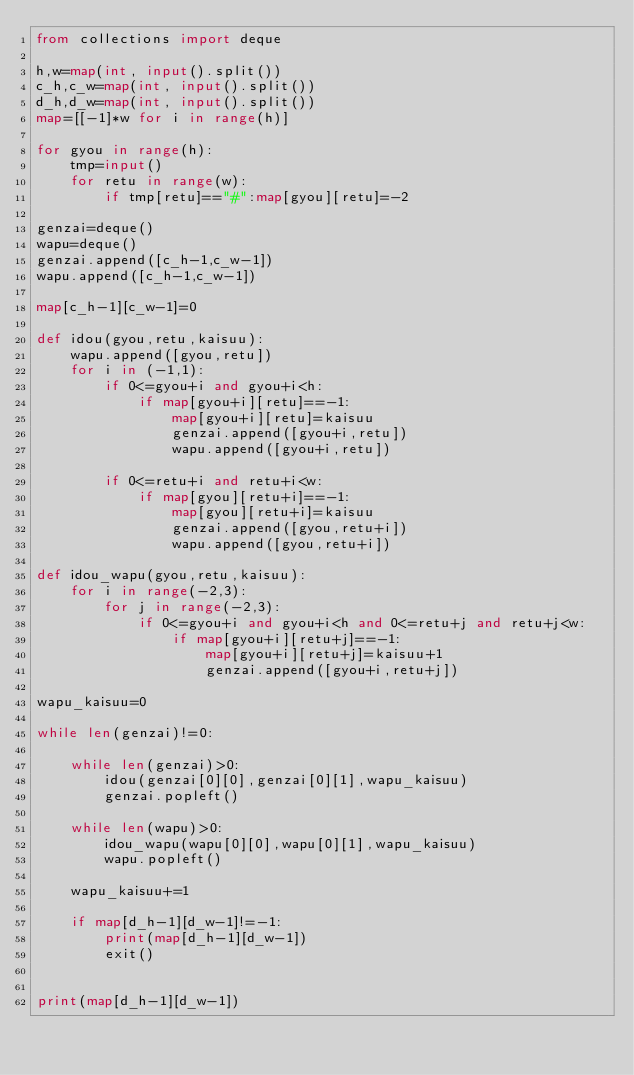<code> <loc_0><loc_0><loc_500><loc_500><_Python_>from collections import deque

h,w=map(int, input().split())
c_h,c_w=map(int, input().split())
d_h,d_w=map(int, input().split())
map=[[-1]*w for i in range(h)]
 
for gyou in range(h):
    tmp=input()
    for retu in range(w):
        if tmp[retu]=="#":map[gyou][retu]=-2
 
genzai=deque()
wapu=deque()
genzai.append([c_h-1,c_w-1])
wapu.append([c_h-1,c_w-1])
 
map[c_h-1][c_w-1]=0
 
def idou(gyou,retu,kaisuu):
    wapu.append([gyou,retu])
    for i in (-1,1):
        if 0<=gyou+i and gyou+i<h:
            if map[gyou+i][retu]==-1:
                map[gyou+i][retu]=kaisuu
                genzai.append([gyou+i,retu])
                wapu.append([gyou+i,retu])
                
        if 0<=retu+i and retu+i<w:
            if map[gyou][retu+i]==-1:
                map[gyou][retu+i]=kaisuu
                genzai.append([gyou,retu+i])
                wapu.append([gyou,retu+i])

def idou_wapu(gyou,retu,kaisuu):
    for i in range(-2,3):
        for j in range(-2,3):
            if 0<=gyou+i and gyou+i<h and 0<=retu+j and retu+j<w:
                if map[gyou+i][retu+j]==-1:
                    map[gyou+i][retu+j]=kaisuu+1
                    genzai.append([gyou+i,retu+j])

wapu_kaisuu=0

while len(genzai)!=0:
 
    while len(genzai)>0:
        idou(genzai[0][0],genzai[0][1],wapu_kaisuu)
        genzai.popleft()
    
    while len(wapu)>0:
        idou_wapu(wapu[0][0],wapu[0][1],wapu_kaisuu)
        wapu.popleft()
    
    wapu_kaisuu+=1

    if map[d_h-1][d_w-1]!=-1:
        print(map[d_h-1][d_w-1])
        exit()


print(map[d_h-1][d_w-1])</code> 